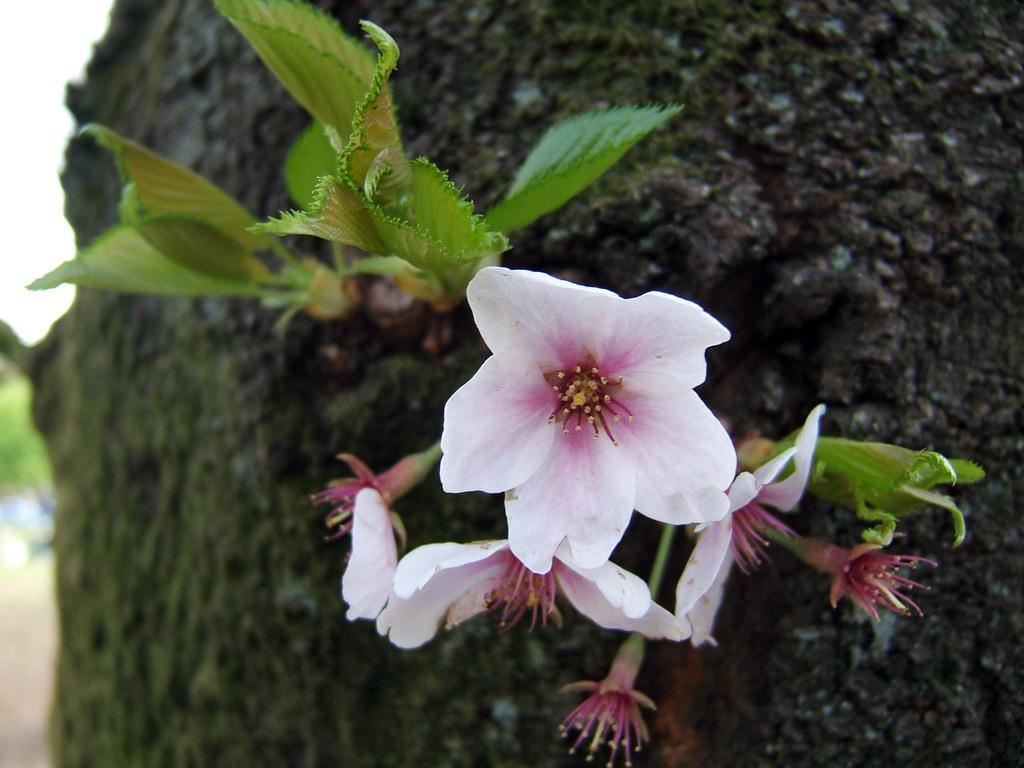What type of plant life can be seen in the image? There are flowers and leaves in the image. What other object is present in the image? There is a rock in the image. What part of the natural environment is visible in the image? The sky is visible in the top left corner of the image. How many jellyfish can be seen swimming in the image? There are no jellyfish present in the image; it features flowers, leaves, a rock, and the sky. 